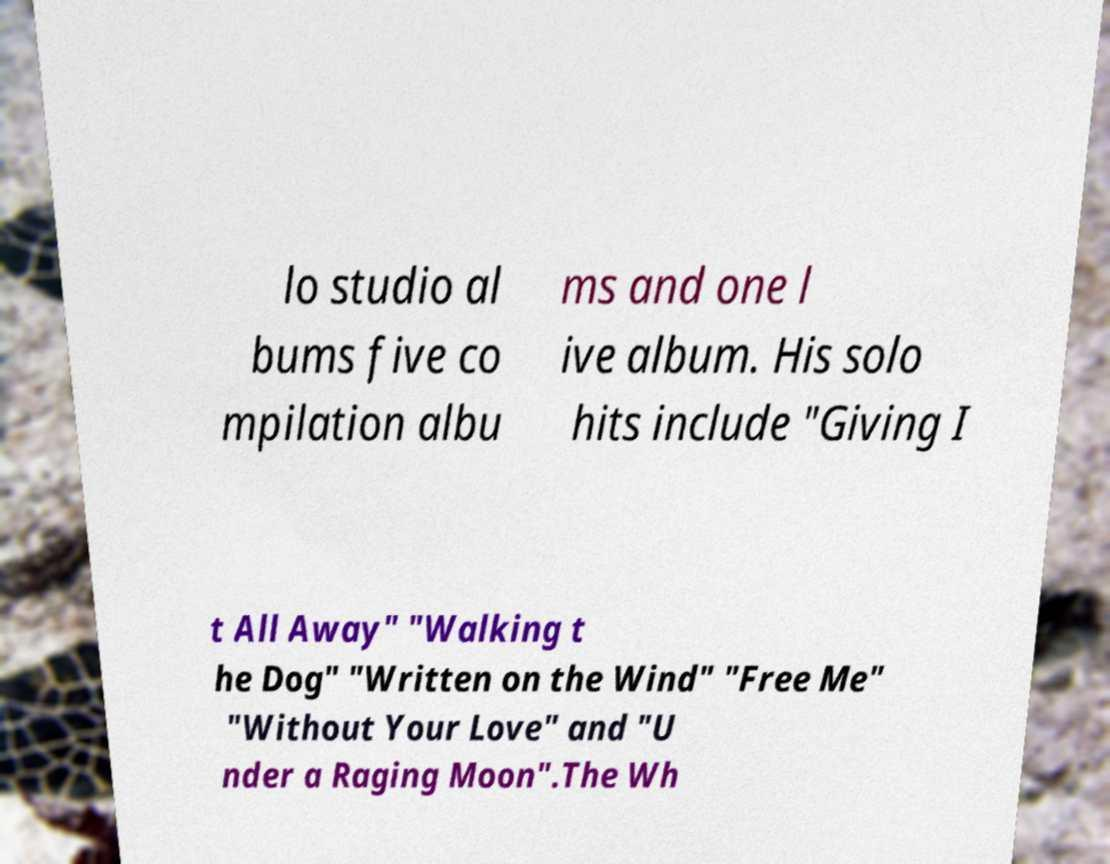I need the written content from this picture converted into text. Can you do that? lo studio al bums five co mpilation albu ms and one l ive album. His solo hits include "Giving I t All Away" "Walking t he Dog" "Written on the Wind" "Free Me" "Without Your Love" and "U nder a Raging Moon".The Wh 